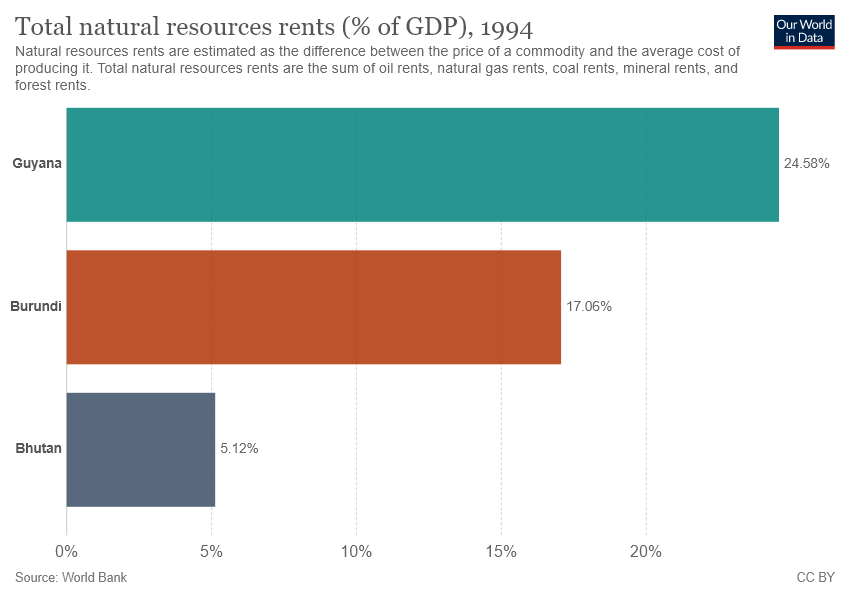Highlight a few significant elements in this photo. The value of the middle bar is approximately 0.1706. To find the average and median percentage of all the bars separately, we need to examine the values of [15.586, 17.06]. 